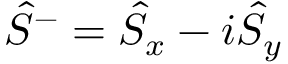Convert formula to latex. <formula><loc_0><loc_0><loc_500><loc_500>\hat { S } ^ { - } = \hat { S } _ { x } - i \hat { S } _ { y }</formula> 